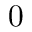Convert formula to latex. <formula><loc_0><loc_0><loc_500><loc_500>0</formula> 